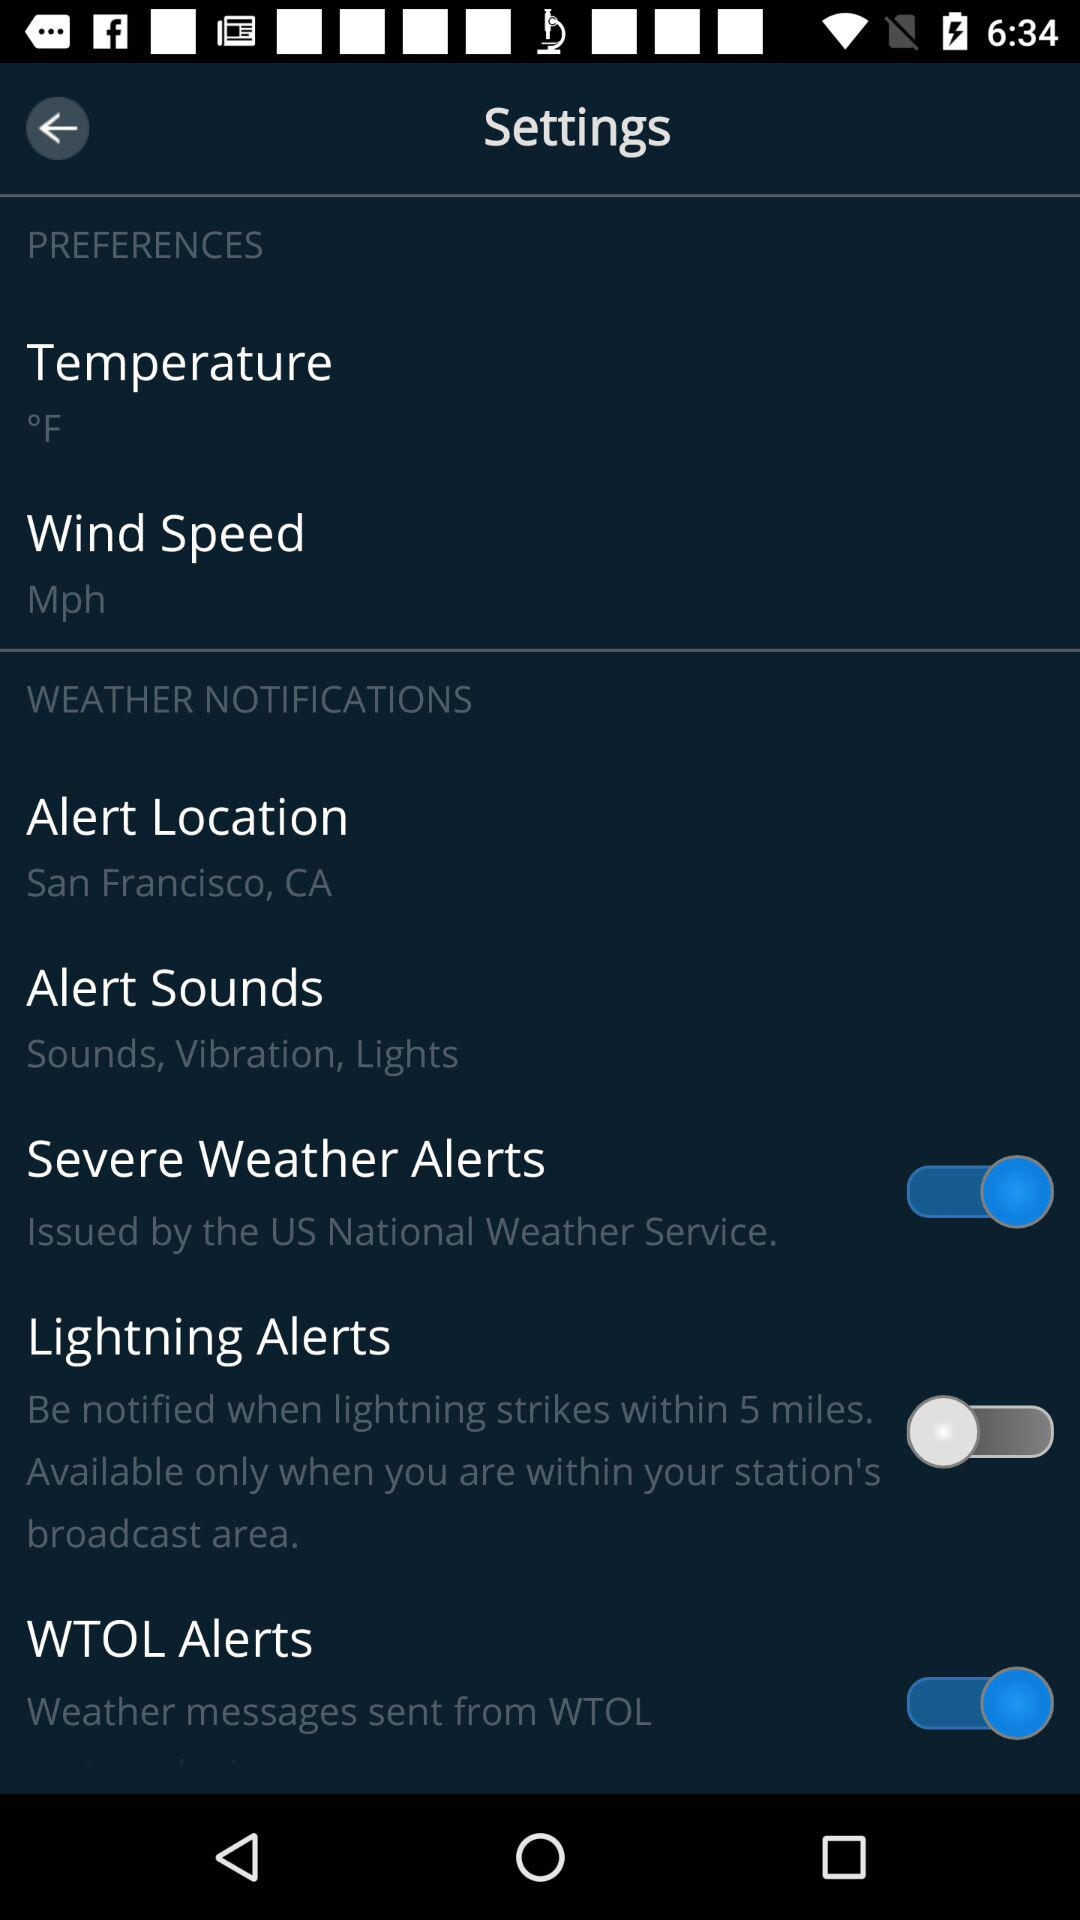In what unit will the temperature be measured? The temperature will be measured in °F. 